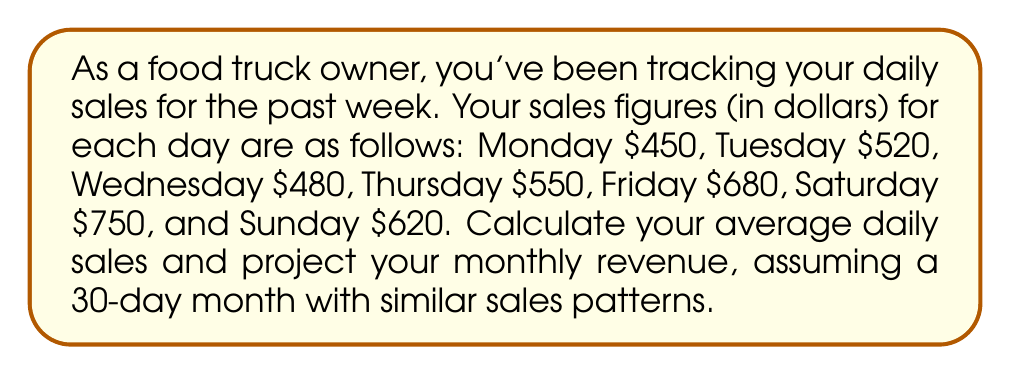Can you solve this math problem? To solve this problem, we'll follow these steps:

1. Calculate the average daily sales:
   a. Add up all the daily sales figures
   b. Divide the sum by the number of days

2. Project the monthly revenue:
   a. Multiply the average daily sales by the number of days in a month

Step 1: Calculate the average daily sales
a. Sum of daily sales:
   $$450 + 520 + 480 + 550 + 680 + 750 + 620 = 4050$$

b. Divide by the number of days (7):
   $$\text{Average Daily Sales} = \frac{4050}{7} = 578.57$$

Step 2: Project the monthly revenue
a. Multiply the average daily sales by 30 days:
   $$\text{Monthly Revenue} = 578.57 \times 30 = 17,357.10$$

Therefore, the average daily sales are $578.57, and the projected monthly revenue is $17,357.10.
Answer: Average Daily Sales: $578.57
Projected Monthly Revenue: $17,357.10 